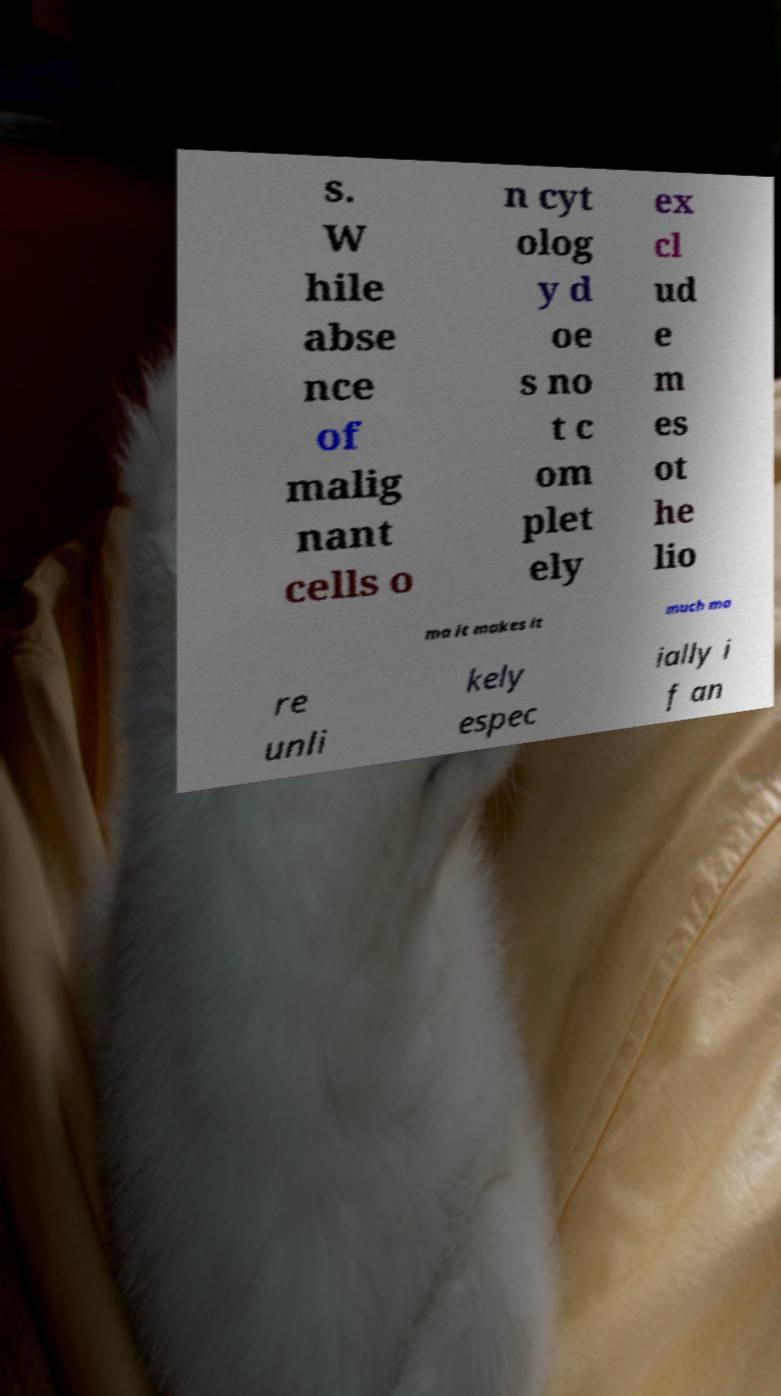For documentation purposes, I need the text within this image transcribed. Could you provide that? s. W hile abse nce of malig nant cells o n cyt olog y d oe s no t c om plet ely ex cl ud e m es ot he lio ma it makes it much mo re unli kely espec ially i f an 